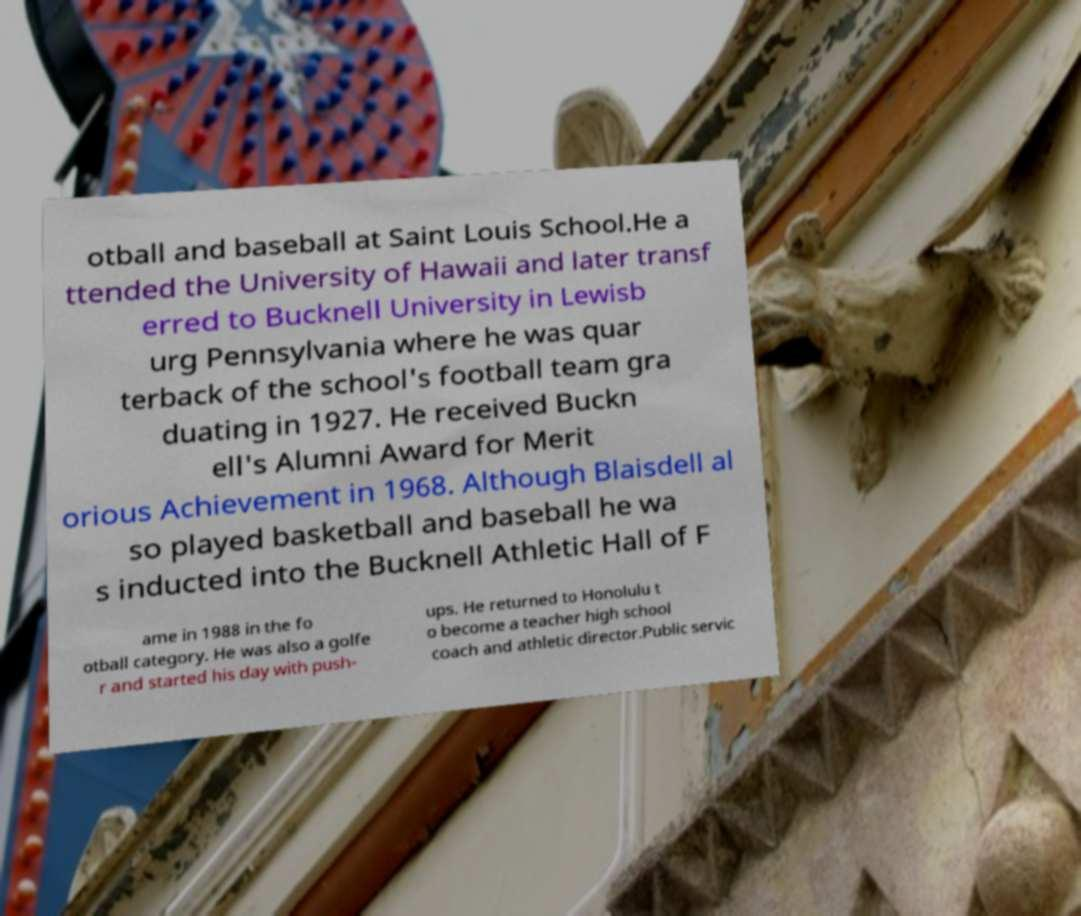Please identify and transcribe the text found in this image. otball and baseball at Saint Louis School.He a ttended the University of Hawaii and later transf erred to Bucknell University in Lewisb urg Pennsylvania where he was quar terback of the school's football team gra duating in 1927. He received Buckn ell's Alumni Award for Merit orious Achievement in 1968. Although Blaisdell al so played basketball and baseball he wa s inducted into the Bucknell Athletic Hall of F ame in 1988 in the fo otball category. He was also a golfe r and started his day with push- ups. He returned to Honolulu t o become a teacher high school coach and athletic director.Public servic 